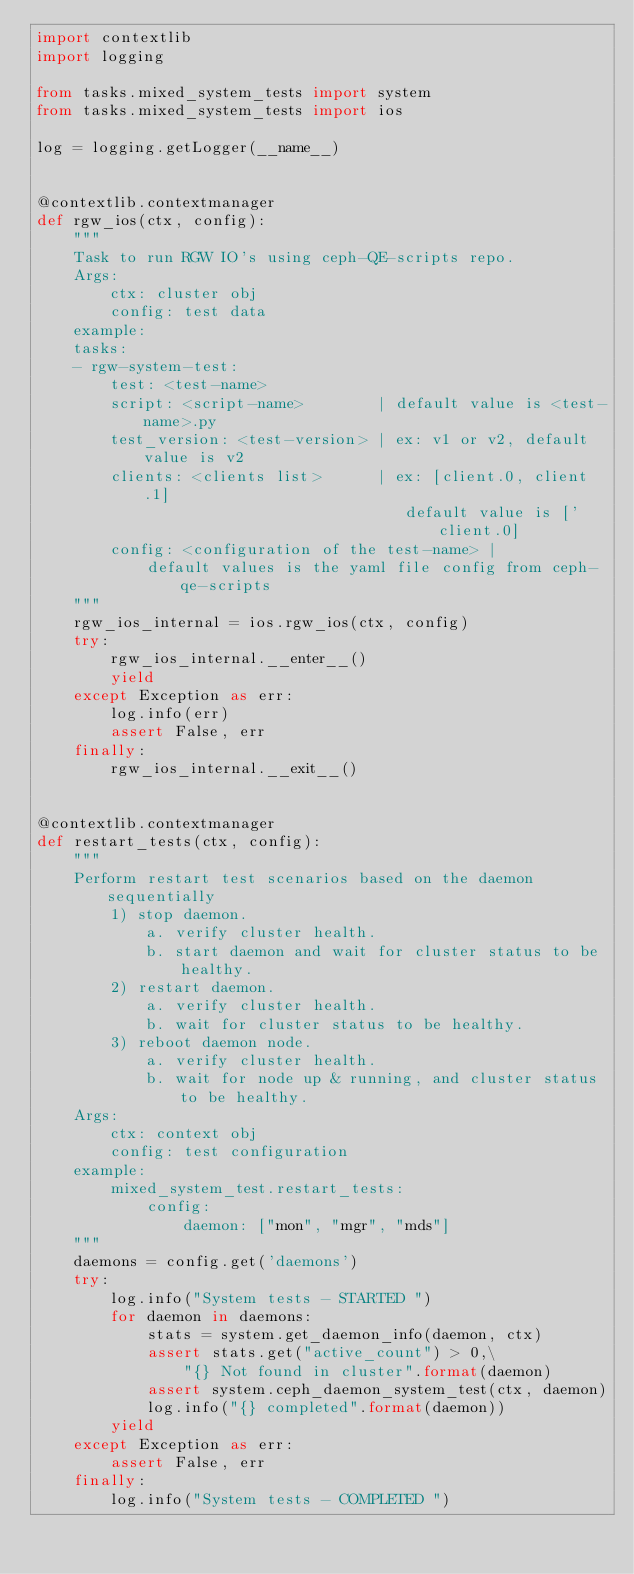Convert code to text. <code><loc_0><loc_0><loc_500><loc_500><_Python_>import contextlib
import logging

from tasks.mixed_system_tests import system
from tasks.mixed_system_tests import ios

log = logging.getLogger(__name__)


@contextlib.contextmanager
def rgw_ios(ctx, config):
    """
    Task to run RGW IO's using ceph-QE-scripts repo.
    Args:
        ctx: cluster obj
        config: test data
    example:
    tasks:
    - rgw-system-test:
        test: <test-name>
        script: <script-name>        | default value is <test-name>.py
        test_version: <test-version> | ex: v1 or v2, default value is v2
        clients: <clients list>      | ex: [client.0, client.1]
                                        default value is ['client.0]
        config: <configuration of the test-name> |
            default values is the yaml file config from ceph-qe-scripts
    """
    rgw_ios_internal = ios.rgw_ios(ctx, config)
    try:
        rgw_ios_internal.__enter__()
        yield
    except Exception as err:
        log.info(err)
        assert False, err
    finally:
        rgw_ios_internal.__exit__()


@contextlib.contextmanager
def restart_tests(ctx, config):
    """
    Perform restart test scenarios based on the daemon sequentially
        1) stop daemon.
            a. verify cluster health.
            b. start daemon and wait for cluster status to be healthy.
        2) restart daemon.
            a. verify cluster health.
            b. wait for cluster status to be healthy.
        3) reboot daemon node.
            a. verify cluster health.
            b. wait for node up & running, and cluster status to be healthy.
    Args:
        ctx: context obj
        config: test configuration
    example:
        mixed_system_test.restart_tests:
            config:
                daemon: ["mon", "mgr", "mds"]
    """
    daemons = config.get('daemons')
    try:
        log.info("System tests - STARTED ")
        for daemon in daemons:
            stats = system.get_daemon_info(daemon, ctx)
            assert stats.get("active_count") > 0,\
                "{} Not found in cluster".format(daemon)
            assert system.ceph_daemon_system_test(ctx, daemon)
            log.info("{} completed".format(daemon))
        yield
    except Exception as err:
        assert False, err
    finally:
        log.info("System tests - COMPLETED ")

</code> 